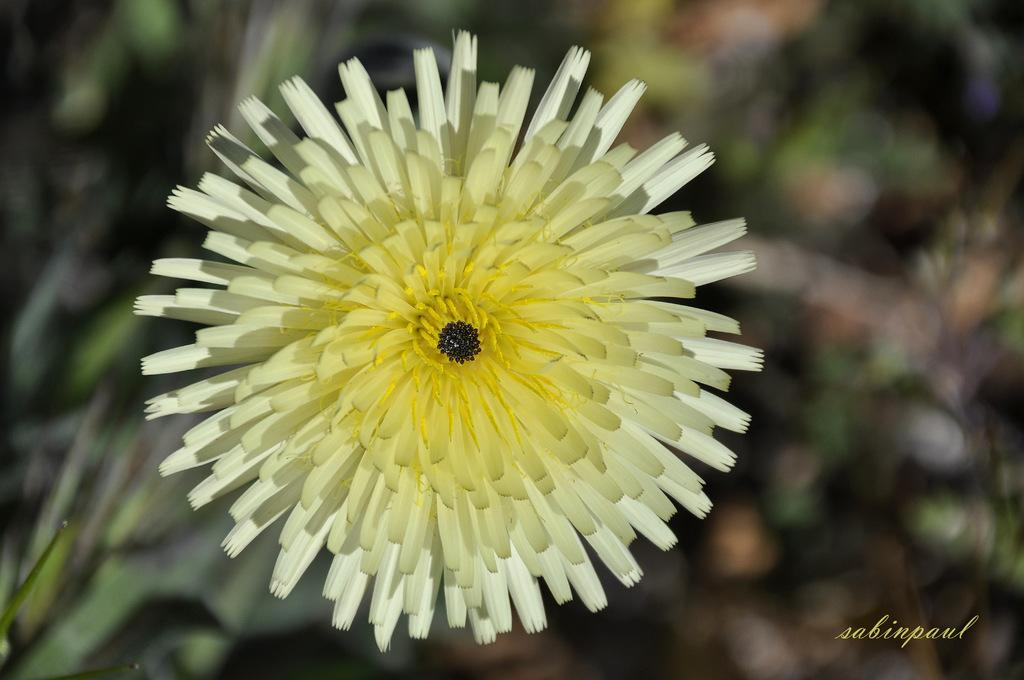What is the main subject of the image? There is a flower present in the image. Can you describe the background of the image? The background of the image is blurry. What type of drug is being used in the religious ceremony depicted in the image? There is no religious ceremony or drug present in the image; it features a flower with a blurry background. 